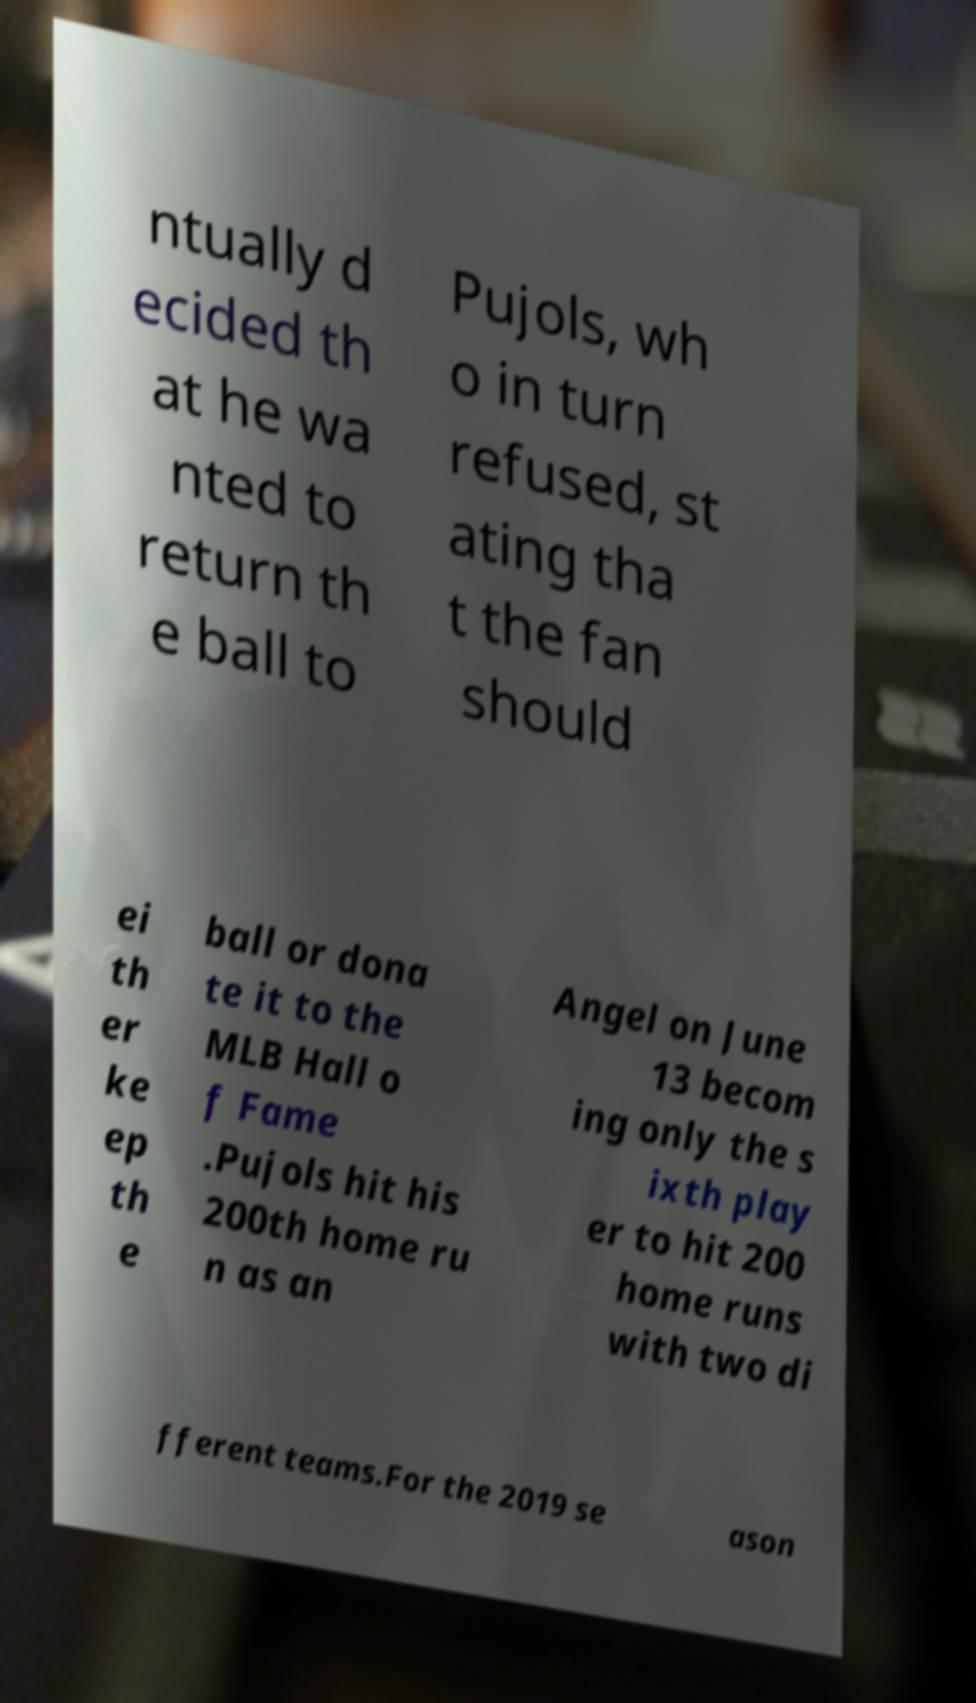Please read and relay the text visible in this image. What does it say? ntually d ecided th at he wa nted to return th e ball to Pujols, wh o in turn refused, st ating tha t the fan should ei th er ke ep th e ball or dona te it to the MLB Hall o f Fame .Pujols hit his 200th home ru n as an Angel on June 13 becom ing only the s ixth play er to hit 200 home runs with two di fferent teams.For the 2019 se ason 